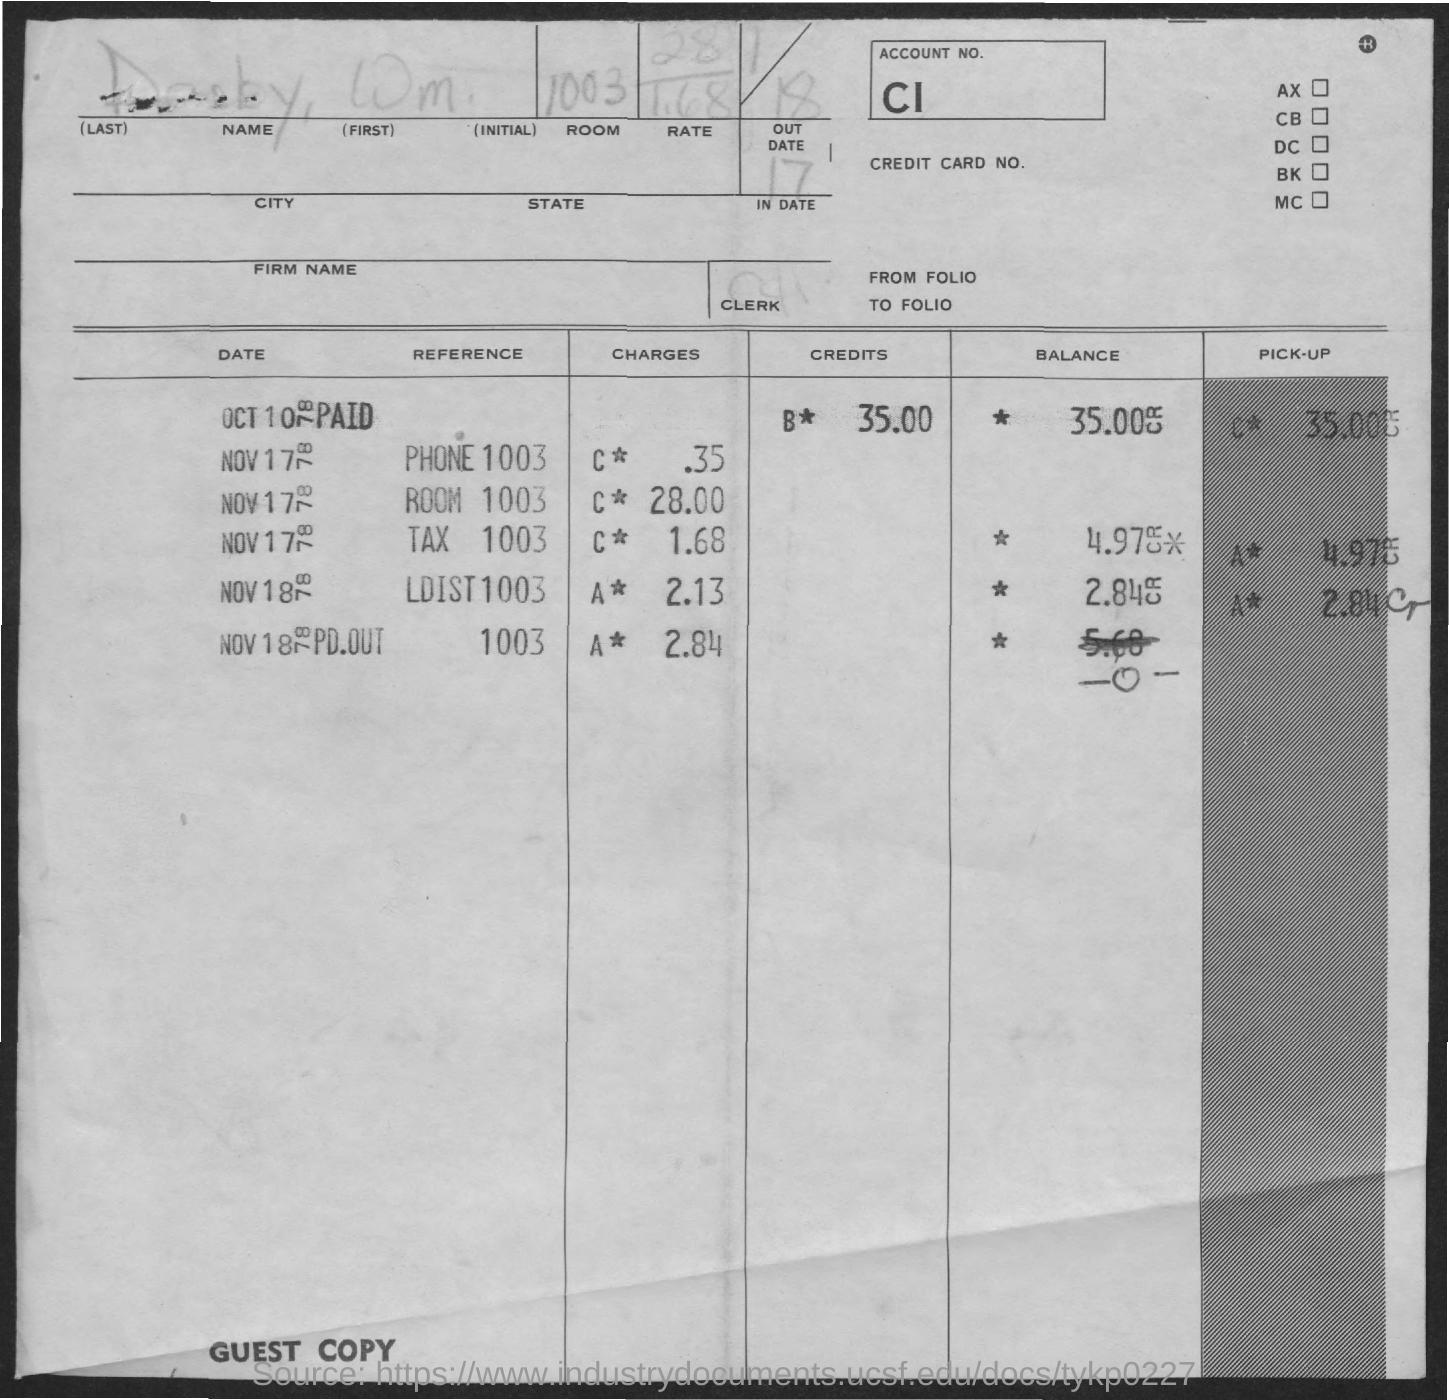Point out several critical features in this image. The LDIST 1003 charges refer to the fees associated with a certain topic or issue. The account number is CI... The room is numbered 1003. The name is DARBY, WM. The Tax 1003 charges are 1.68... 